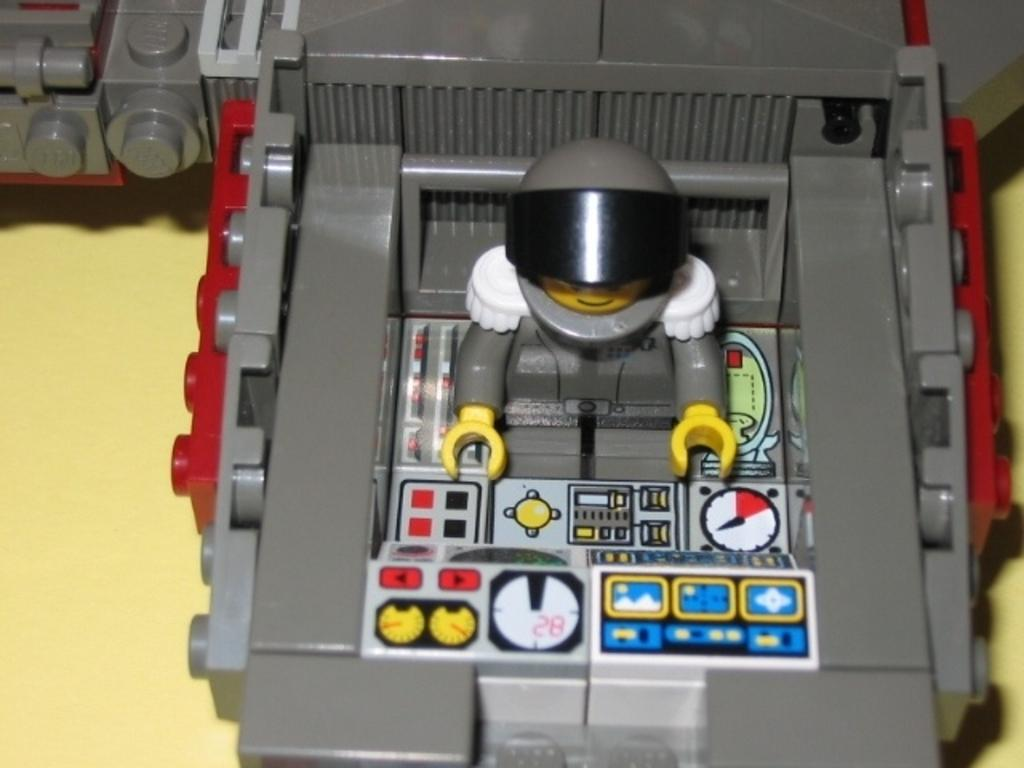What object is placed on the surface in the image? There is a toy on the surface in the image. What type of credit can be seen in the image? There is no credit present in the image; it features a toy on a surface. How many potatoes are visible in the image? There are no potatoes present in the image. 